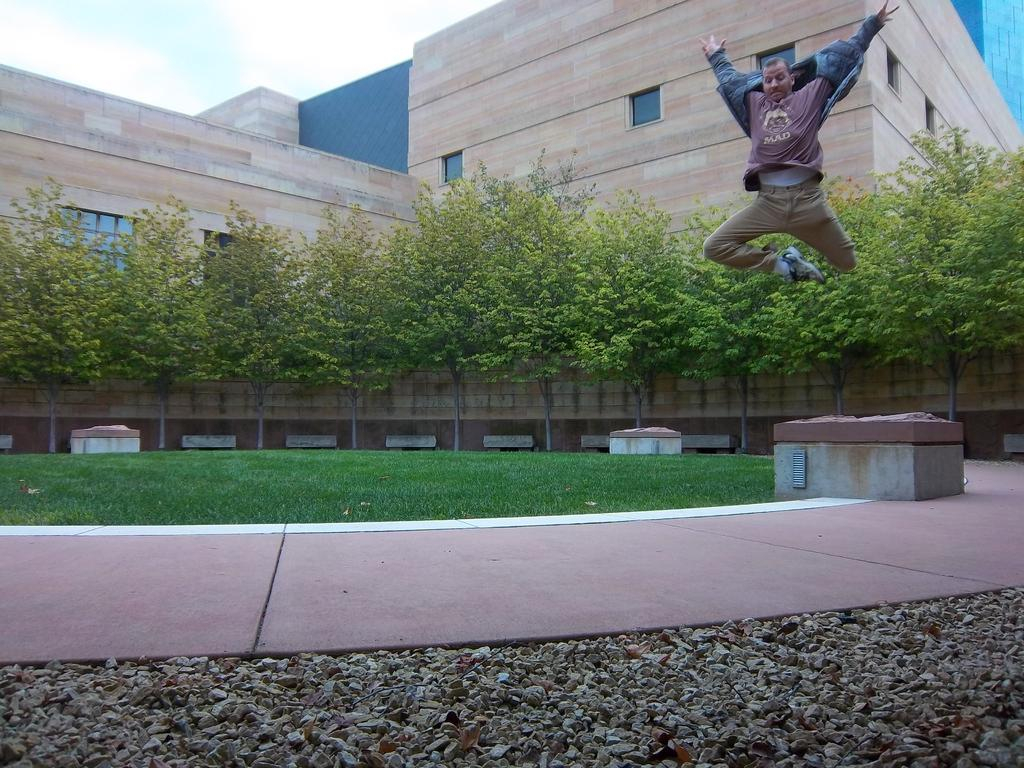Who is the main subject in the image? There is a man in the image. What is the man doing in the image? The man is jumping. What type of environment is visible in the image? The surroundings include grass, trees, and buildings. How many feet are visible on the man's hands in the image? The man's hands are not visible in the image, and therefore, no feet can be seen on them. 